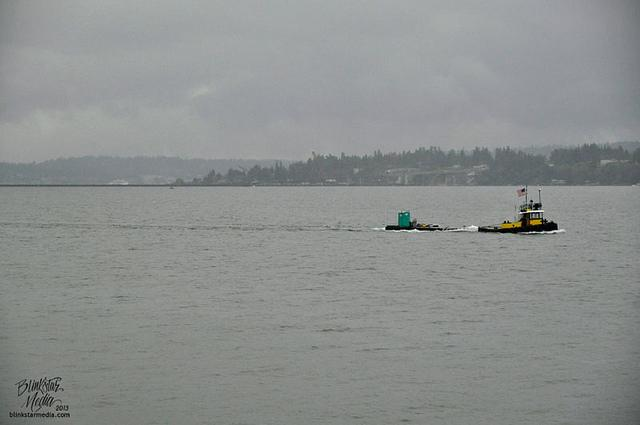The green object on the smaller boat is used as what? Please explain your reasoning. restroom. The green object is a portable toilet. 